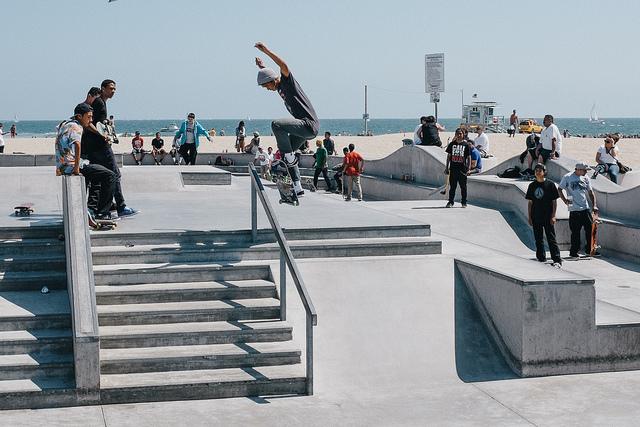Is the guy skateboarding wearing protective gear?
Write a very short answer. No. Are they at a skate park?
Concise answer only. Yes. What color is the shirt of the man watching the skateboarder?
Quick response, please. Black. Are these people camping?
Write a very short answer. No. What is the person in the orange doing?
Be succinct. Standing. 